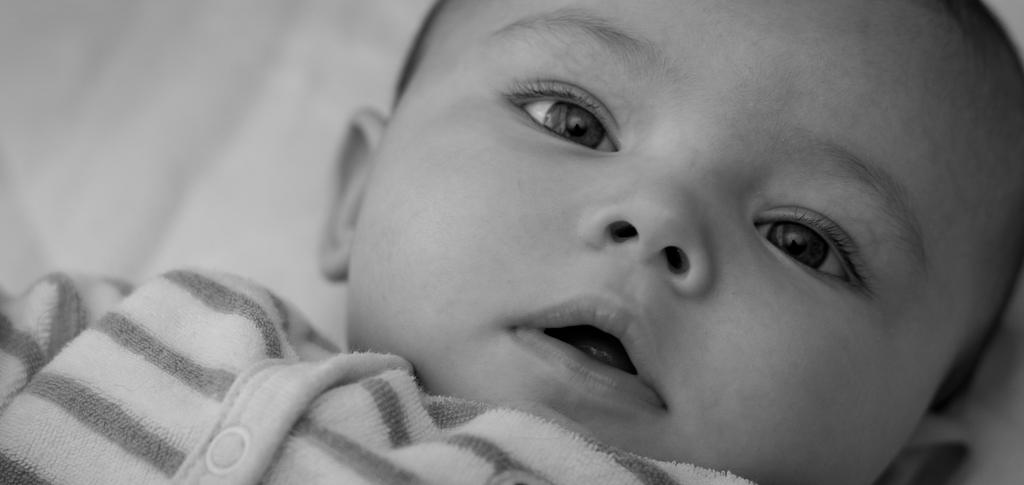What is the color scheme of the image? The image is black and white. What subject is depicted in the image? There is a baby in the image. What type of disease is affecting the baby in the image? There is no indication of any disease affecting the baby in the image, as the image only shows a baby and does not provide any information about the baby's health. 